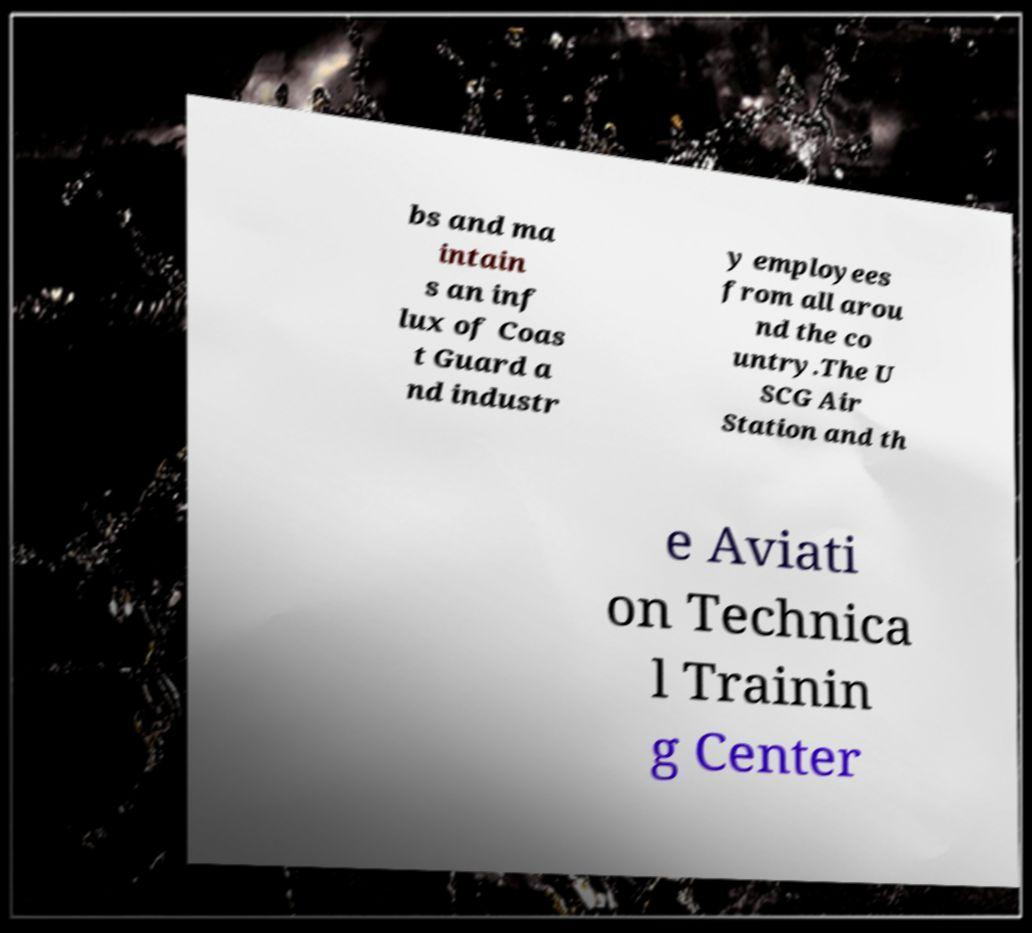Can you accurately transcribe the text from the provided image for me? bs and ma intain s an inf lux of Coas t Guard a nd industr y employees from all arou nd the co untry.The U SCG Air Station and th e Aviati on Technica l Trainin g Center 